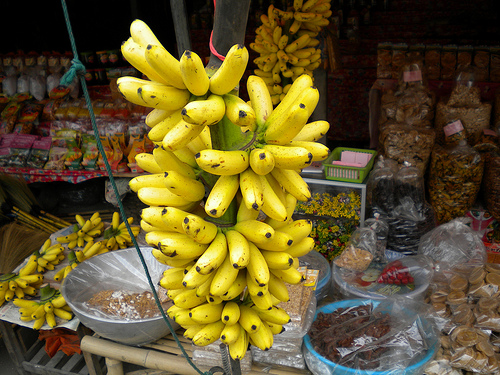Please provide a short description for this region: [0.51, 0.4, 0.62, 0.46]. The region features a bunch of ripe yellow bananas, likely handpicked and displayed for sale, adding a vibrant splash of color to the market scene. 